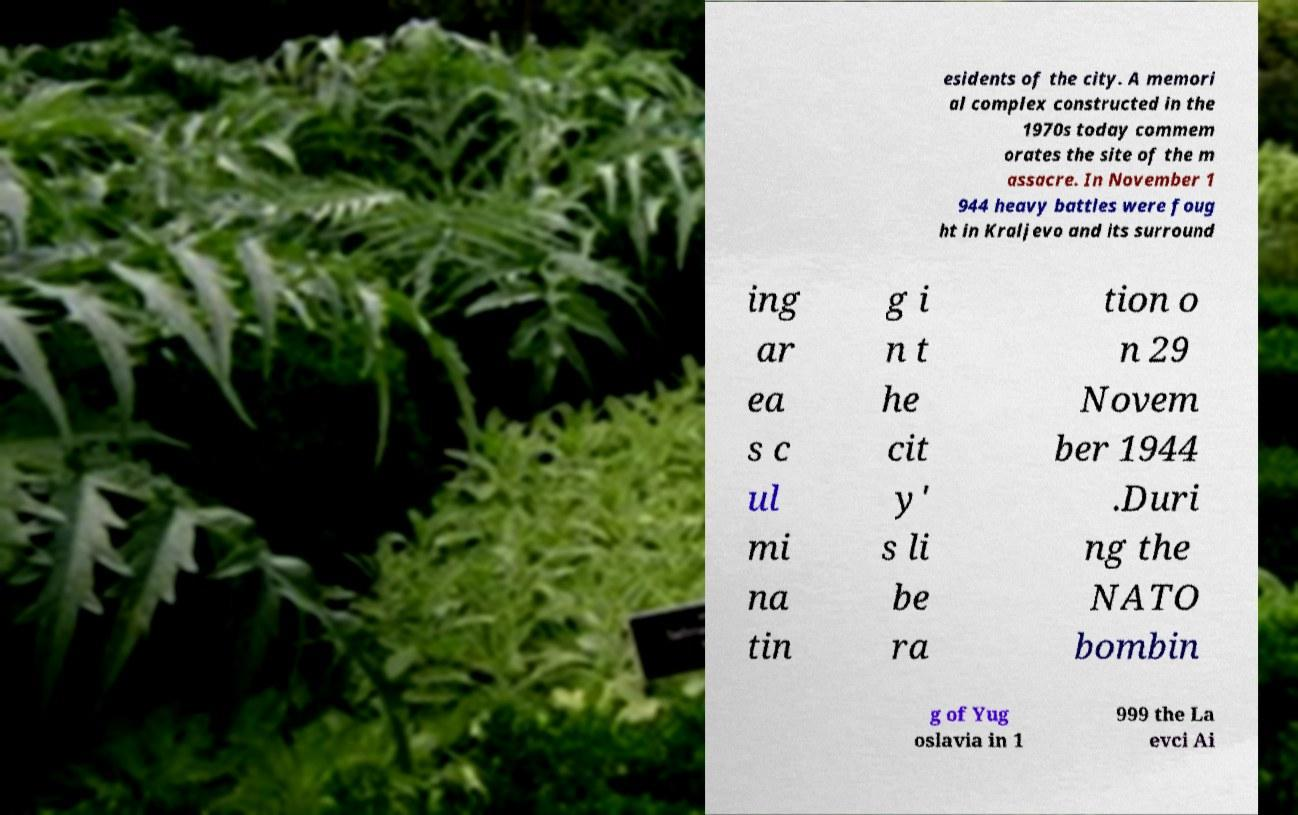Could you extract and type out the text from this image? esidents of the city. A memori al complex constructed in the 1970s today commem orates the site of the m assacre. In November 1 944 heavy battles were foug ht in Kraljevo and its surround ing ar ea s c ul mi na tin g i n t he cit y' s li be ra tion o n 29 Novem ber 1944 .Duri ng the NATO bombin g of Yug oslavia in 1 999 the La evci Ai 